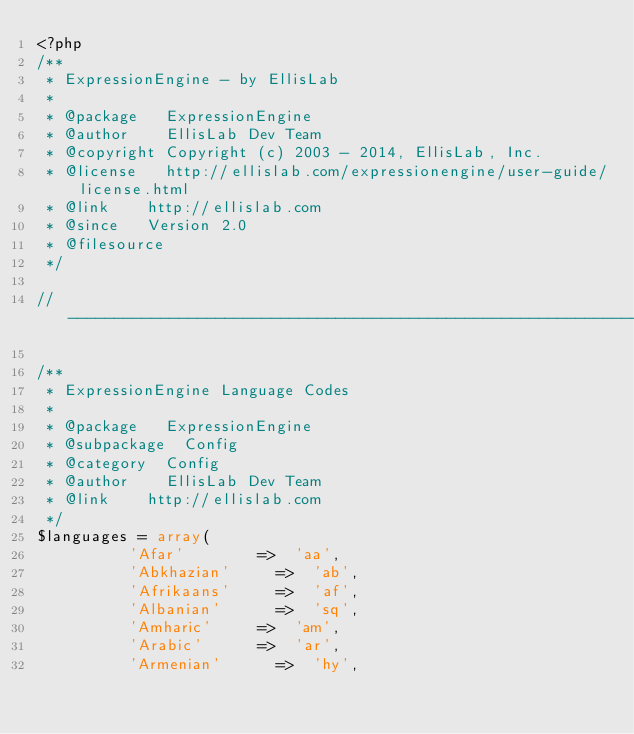Convert code to text. <code><loc_0><loc_0><loc_500><loc_500><_PHP_><?php
/**
 * ExpressionEngine - by EllisLab
 *
 * @package		ExpressionEngine
 * @author		EllisLab Dev Team
 * @copyright	Copyright (c) 2003 - 2014, EllisLab, Inc.
 * @license		http://ellislab.com/expressionengine/user-guide/license.html
 * @link		http://ellislab.com
 * @since		Version 2.0
 * @filesource
 */

// ------------------------------------------------------------------------

/**
 * ExpressionEngine Language Codes
 *
 * @package		ExpressionEngine
 * @subpackage	Config
 * @category	Config
 * @author		EllisLab Dev Team
 * @link		http://ellislab.com
 */
$languages = array(
					'Afar'				=>	'aa',
					'Abkhazian'			=>	'ab',
					'Afrikaans'			=>	'af',
					'Albanian'			=>	'sq',
					'Amharic'			=>	'am',
					'Arabic'			=>	'ar',
					'Armenian'			=>	'hy',</code> 